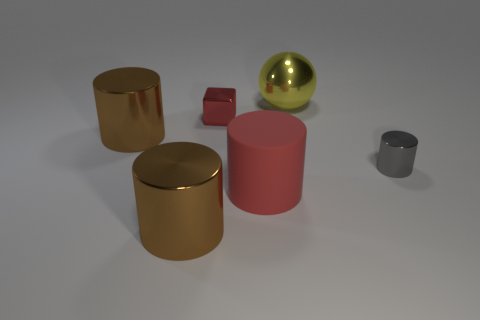Subtract all purple balls. Subtract all green cubes. How many balls are left? 1 Add 3 tiny gray metallic things. How many objects exist? 9 Subtract all cylinders. How many objects are left? 2 Subtract 0 cyan blocks. How many objects are left? 6 Subtract all purple cylinders. Subtract all red objects. How many objects are left? 4 Add 6 big brown things. How many big brown things are left? 8 Add 3 green cylinders. How many green cylinders exist? 3 